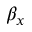<formula> <loc_0><loc_0><loc_500><loc_500>\beta _ { x }</formula> 